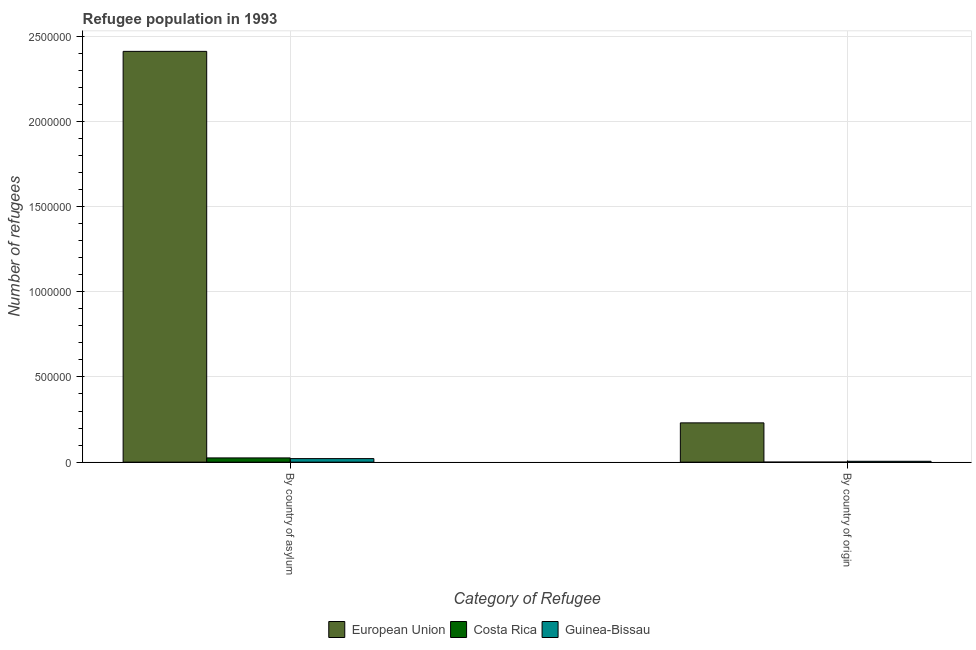How many different coloured bars are there?
Your answer should be compact. 3. Are the number of bars per tick equal to the number of legend labels?
Your answer should be very brief. Yes. What is the label of the 2nd group of bars from the left?
Your answer should be very brief. By country of origin. What is the number of refugees by country of asylum in European Union?
Offer a very short reply. 2.41e+06. Across all countries, what is the maximum number of refugees by country of origin?
Your answer should be very brief. 2.30e+05. Across all countries, what is the minimum number of refugees by country of asylum?
Offer a terse response. 2.07e+04. In which country was the number of refugees by country of origin maximum?
Offer a very short reply. European Union. In which country was the number of refugees by country of asylum minimum?
Give a very brief answer. Guinea-Bissau. What is the total number of refugees by country of origin in the graph?
Your response must be concise. 2.35e+05. What is the difference between the number of refugees by country of origin in Costa Rica and that in European Union?
Your response must be concise. -2.30e+05. What is the difference between the number of refugees by country of origin in Guinea-Bissau and the number of refugees by country of asylum in European Union?
Offer a terse response. -2.40e+06. What is the average number of refugees by country of asylum per country?
Your answer should be compact. 8.19e+05. What is the difference between the number of refugees by country of origin and number of refugees by country of asylum in Guinea-Bissau?
Provide a short and direct response. -1.57e+04. What is the ratio of the number of refugees by country of asylum in Guinea-Bissau to that in Costa Rica?
Keep it short and to the point. 0.83. Is the number of refugees by country of asylum in European Union less than that in Costa Rica?
Make the answer very short. No. What does the 2nd bar from the left in By country of asylum represents?
Your answer should be very brief. Costa Rica. What does the 3rd bar from the right in By country of origin represents?
Keep it short and to the point. European Union. How many bars are there?
Your answer should be very brief. 6. Are all the bars in the graph horizontal?
Provide a succinct answer. No. Are the values on the major ticks of Y-axis written in scientific E-notation?
Offer a very short reply. No. Does the graph contain any zero values?
Offer a terse response. No. Does the graph contain grids?
Provide a short and direct response. Yes. Where does the legend appear in the graph?
Provide a short and direct response. Bottom center. How are the legend labels stacked?
Your response must be concise. Horizontal. What is the title of the graph?
Provide a short and direct response. Refugee population in 1993. What is the label or title of the X-axis?
Provide a succinct answer. Category of Refugee. What is the label or title of the Y-axis?
Your answer should be very brief. Number of refugees. What is the Number of refugees in European Union in By country of asylum?
Provide a succinct answer. 2.41e+06. What is the Number of refugees of Costa Rica in By country of asylum?
Give a very brief answer. 2.48e+04. What is the Number of refugees in Guinea-Bissau in By country of asylum?
Your response must be concise. 2.07e+04. What is the Number of refugees in European Union in By country of origin?
Provide a succinct answer. 2.30e+05. What is the Number of refugees of Costa Rica in By country of origin?
Give a very brief answer. 5. What is the Number of refugees of Guinea-Bissau in By country of origin?
Provide a short and direct response. 5011. Across all Category of Refugee, what is the maximum Number of refugees of European Union?
Your answer should be compact. 2.41e+06. Across all Category of Refugee, what is the maximum Number of refugees in Costa Rica?
Offer a very short reply. 2.48e+04. Across all Category of Refugee, what is the maximum Number of refugees in Guinea-Bissau?
Offer a terse response. 2.07e+04. Across all Category of Refugee, what is the minimum Number of refugees in European Union?
Keep it short and to the point. 2.30e+05. Across all Category of Refugee, what is the minimum Number of refugees of Guinea-Bissau?
Your answer should be compact. 5011. What is the total Number of refugees of European Union in the graph?
Make the answer very short. 2.64e+06. What is the total Number of refugees in Costa Rica in the graph?
Make the answer very short. 2.48e+04. What is the total Number of refugees of Guinea-Bissau in the graph?
Ensure brevity in your answer.  2.57e+04. What is the difference between the Number of refugees in European Union in By country of asylum and that in By country of origin?
Provide a succinct answer. 2.18e+06. What is the difference between the Number of refugees in Costa Rica in By country of asylum and that in By country of origin?
Give a very brief answer. 2.48e+04. What is the difference between the Number of refugees of Guinea-Bissau in By country of asylum and that in By country of origin?
Ensure brevity in your answer.  1.57e+04. What is the difference between the Number of refugees in European Union in By country of asylum and the Number of refugees in Costa Rica in By country of origin?
Your answer should be very brief. 2.41e+06. What is the difference between the Number of refugees in European Union in By country of asylum and the Number of refugees in Guinea-Bissau in By country of origin?
Keep it short and to the point. 2.40e+06. What is the difference between the Number of refugees in Costa Rica in By country of asylum and the Number of refugees in Guinea-Bissau in By country of origin?
Give a very brief answer. 1.98e+04. What is the average Number of refugees of European Union per Category of Refugee?
Your answer should be compact. 1.32e+06. What is the average Number of refugees of Costa Rica per Category of Refugee?
Offer a very short reply. 1.24e+04. What is the average Number of refugees of Guinea-Bissau per Category of Refugee?
Provide a short and direct response. 1.29e+04. What is the difference between the Number of refugees in European Union and Number of refugees in Costa Rica in By country of asylum?
Provide a succinct answer. 2.39e+06. What is the difference between the Number of refugees in European Union and Number of refugees in Guinea-Bissau in By country of asylum?
Your answer should be very brief. 2.39e+06. What is the difference between the Number of refugees in Costa Rica and Number of refugees in Guinea-Bissau in By country of asylum?
Give a very brief answer. 4099. What is the difference between the Number of refugees of European Union and Number of refugees of Costa Rica in By country of origin?
Your answer should be very brief. 2.30e+05. What is the difference between the Number of refugees in European Union and Number of refugees in Guinea-Bissau in By country of origin?
Make the answer very short. 2.25e+05. What is the difference between the Number of refugees of Costa Rica and Number of refugees of Guinea-Bissau in By country of origin?
Your answer should be very brief. -5006. What is the ratio of the Number of refugees in European Union in By country of asylum to that in By country of origin?
Provide a short and direct response. 10.46. What is the ratio of the Number of refugees in Costa Rica in By country of asylum to that in By country of origin?
Keep it short and to the point. 4966.8. What is the ratio of the Number of refugees of Guinea-Bissau in By country of asylum to that in By country of origin?
Your answer should be very brief. 4.14. What is the difference between the highest and the second highest Number of refugees in European Union?
Provide a succinct answer. 2.18e+06. What is the difference between the highest and the second highest Number of refugees of Costa Rica?
Your answer should be compact. 2.48e+04. What is the difference between the highest and the second highest Number of refugees of Guinea-Bissau?
Offer a terse response. 1.57e+04. What is the difference between the highest and the lowest Number of refugees in European Union?
Your response must be concise. 2.18e+06. What is the difference between the highest and the lowest Number of refugees in Costa Rica?
Provide a short and direct response. 2.48e+04. What is the difference between the highest and the lowest Number of refugees in Guinea-Bissau?
Make the answer very short. 1.57e+04. 